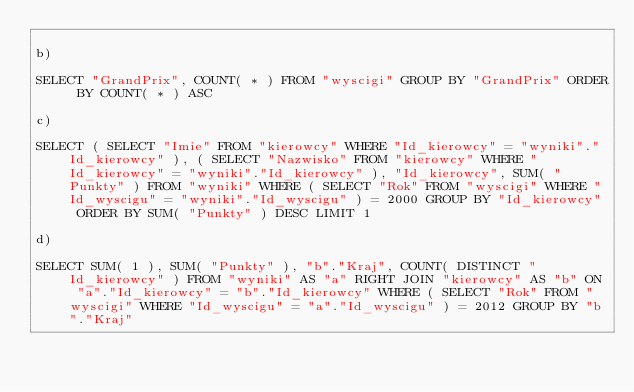Convert code to text. <code><loc_0><loc_0><loc_500><loc_500><_SQL_>
b)

SELECT "GrandPrix", COUNT( * ) FROM "wyscigi" GROUP BY "GrandPrix" ORDER BY COUNT( * ) ASC

c)

SELECT ( SELECT "Imie" FROM "kierowcy" WHERE "Id_kierowcy" = "wyniki"."Id_kierowcy" ), ( SELECT "Nazwisko" FROM "kierowcy" WHERE "Id_kierowcy" = "wyniki"."Id_kierowcy" ), "Id_kierowcy", SUM( "Punkty" ) FROM "wyniki" WHERE ( SELECT "Rok" FROM "wyscigi" WHERE "Id_wyscigu" = "wyniki"."Id_wyscigu" ) = 2000 GROUP BY "Id_kierowcy" ORDER BY SUM( "Punkty" ) DESC LIMIT 1

d)

SELECT SUM( 1 ), SUM( "Punkty" ), "b"."Kraj", COUNT( DISTINCT "Id_kierowcy" ) FROM "wyniki" AS "a" RIGHT JOIN "kierowcy" AS "b" ON "a"."Id_kierowcy" = "b"."Id_kierowcy" WHERE ( SELECT "Rok" FROM "wyscigi" WHERE "Id_wyscigu" = "a"."Id_wyscigu" ) = 2012 GROUP BY "b"."Kraj"
</code> 